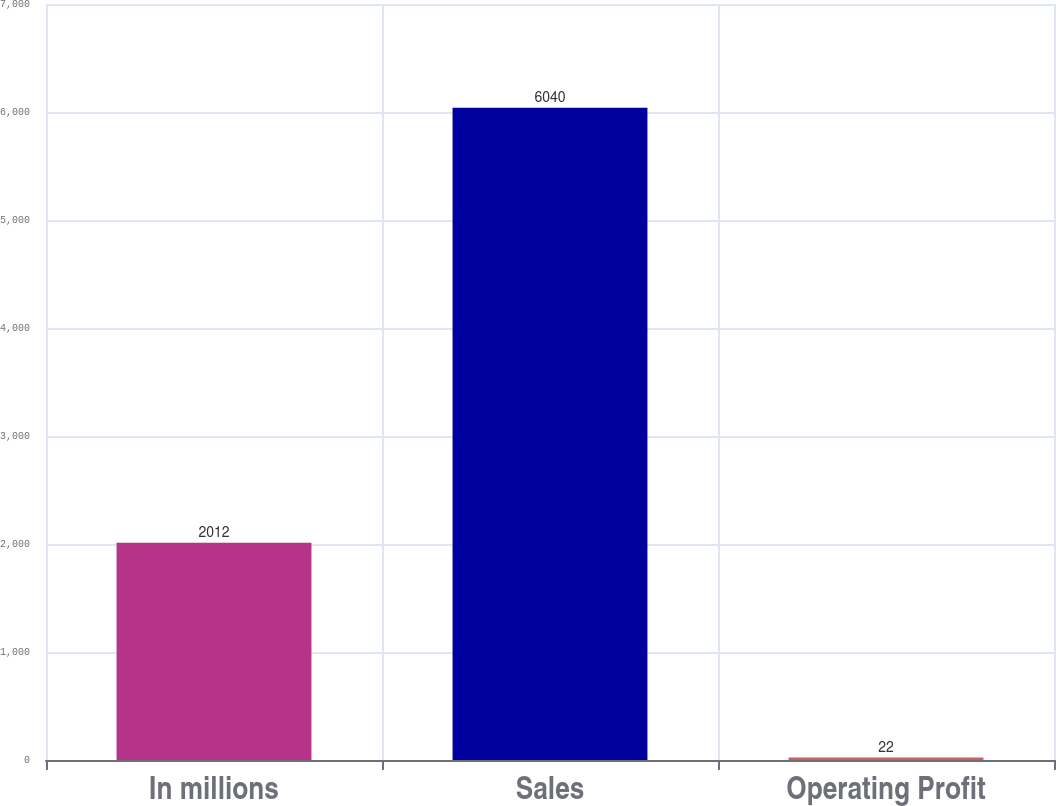<chart> <loc_0><loc_0><loc_500><loc_500><bar_chart><fcel>In millions<fcel>Sales<fcel>Operating Profit<nl><fcel>2012<fcel>6040<fcel>22<nl></chart> 